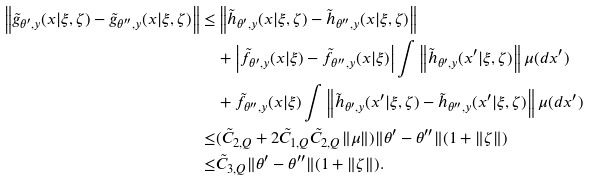Convert formula to latex. <formula><loc_0><loc_0><loc_500><loc_500>\left \| \tilde { g } _ { \theta ^ { \prime } , y } ( x | \xi , \zeta ) - \tilde { g } _ { \theta ^ { \prime \prime } , y } ( x | \xi , \zeta ) \right \| \leq & \left \| \tilde { h } _ { \theta ^ { \prime } , y } ( x | \xi , \zeta ) - \tilde { h } _ { \theta ^ { \prime \prime } , y } ( x | \xi , \zeta ) \right \| \\ & + \left | \tilde { f } _ { \theta ^ { \prime } , y } ( x | \xi ) - \tilde { f } _ { \theta ^ { \prime \prime } , y } ( x | \xi ) \right | \int \left \| \tilde { h } _ { \theta ^ { \prime } , y } ( x ^ { \prime } | \xi , \zeta ) \right \| \mu ( d x ^ { \prime } ) \\ & + \tilde { f } _ { \theta ^ { \prime \prime } , y } ( x | \xi ) \int \left \| \tilde { h } _ { \theta ^ { \prime } , y } ( x ^ { \prime } | \xi , \zeta ) - \tilde { h } _ { \theta ^ { \prime \prime } , y } ( x ^ { \prime } | \xi , \zeta ) \right \| \mu ( d x ^ { \prime } ) \\ \leq & ( \tilde { C } _ { 2 , Q } + 2 \tilde { C } _ { 1 , Q } \tilde { C } _ { 2 , Q } \| \mu \| ) \| \theta ^ { \prime } - \theta ^ { \prime \prime } \| ( 1 + \| \zeta \| ) \\ \leq & \tilde { C } _ { 3 , Q } \| \theta ^ { \prime } - \theta ^ { \prime \prime } \| ( 1 + \| \zeta \| ) .</formula> 